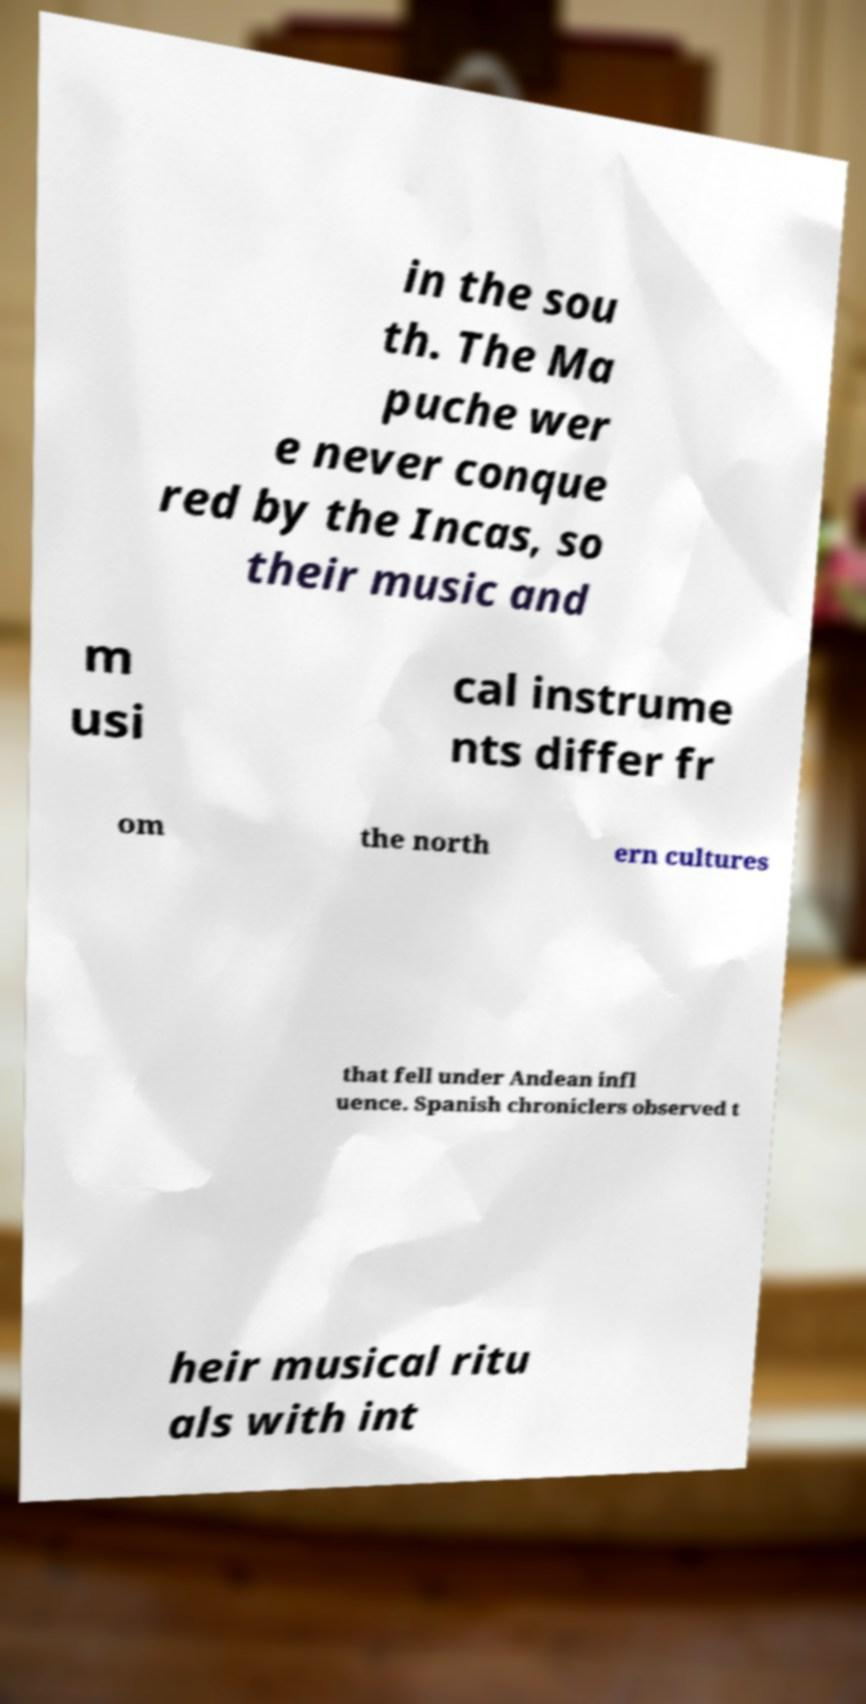For documentation purposes, I need the text within this image transcribed. Could you provide that? in the sou th. The Ma puche wer e never conque red by the Incas, so their music and m usi cal instrume nts differ fr om the north ern cultures that fell under Andean infl uence. Spanish chroniclers observed t heir musical ritu als with int 